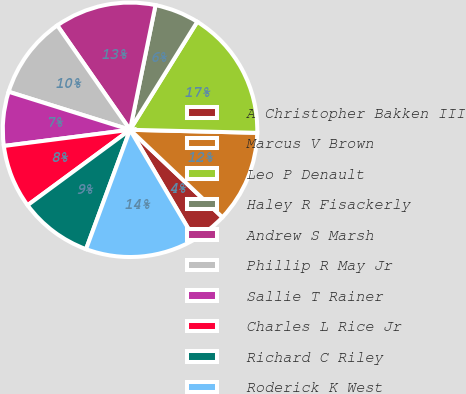<chart> <loc_0><loc_0><loc_500><loc_500><pie_chart><fcel>A Christopher Bakken III<fcel>Marcus V Brown<fcel>Leo P Denault<fcel>Haley R Fisackerly<fcel>Andrew S Marsh<fcel>Phillip R May Jr<fcel>Sallie T Rainer<fcel>Charles L Rice Jr<fcel>Richard C Riley<fcel>Roderick K West<nl><fcel>4.45%<fcel>11.69%<fcel>16.52%<fcel>5.65%<fcel>12.9%<fcel>10.48%<fcel>6.86%<fcel>8.07%<fcel>9.28%<fcel>14.1%<nl></chart> 